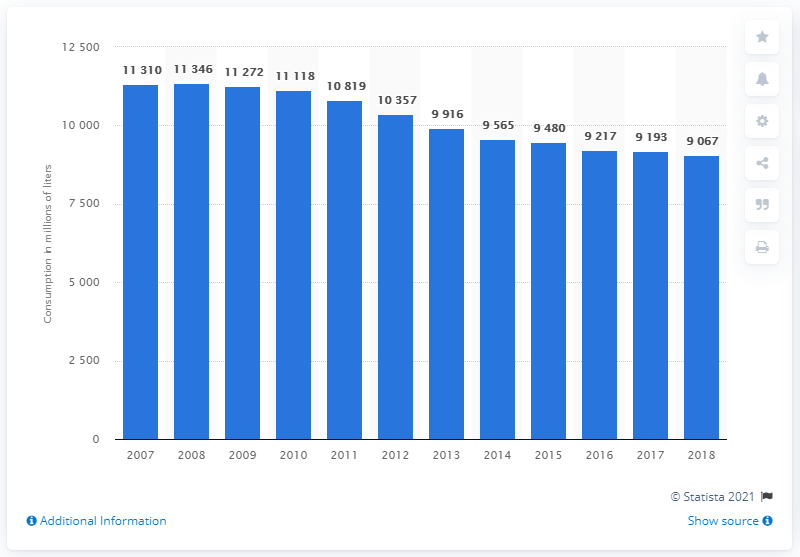Highlight a few significant elements in this photo. In 2018, the total amount of fruit juice and fruit nectar consumed in the 28 European Union countries was approximately 9,067 metric tons. 